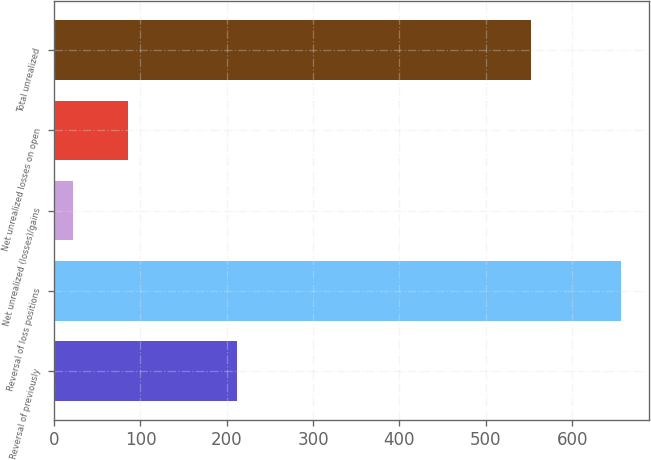Convert chart. <chart><loc_0><loc_0><loc_500><loc_500><bar_chart><fcel>Reversal of previously<fcel>Reversal of loss positions<fcel>Net unrealized (losses)/gains<fcel>Net unrealized losses on open<fcel>Total unrealized<nl><fcel>212.2<fcel>656<fcel>22<fcel>85.4<fcel>552<nl></chart> 